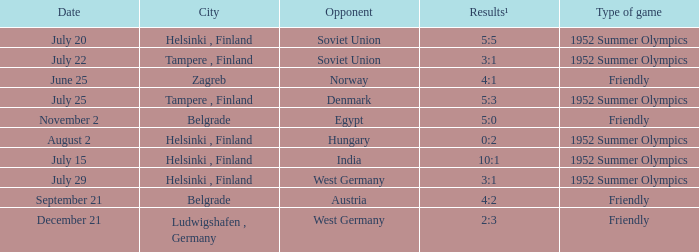On july 29, what kind of game took place? 1952 Summer Olympics. 